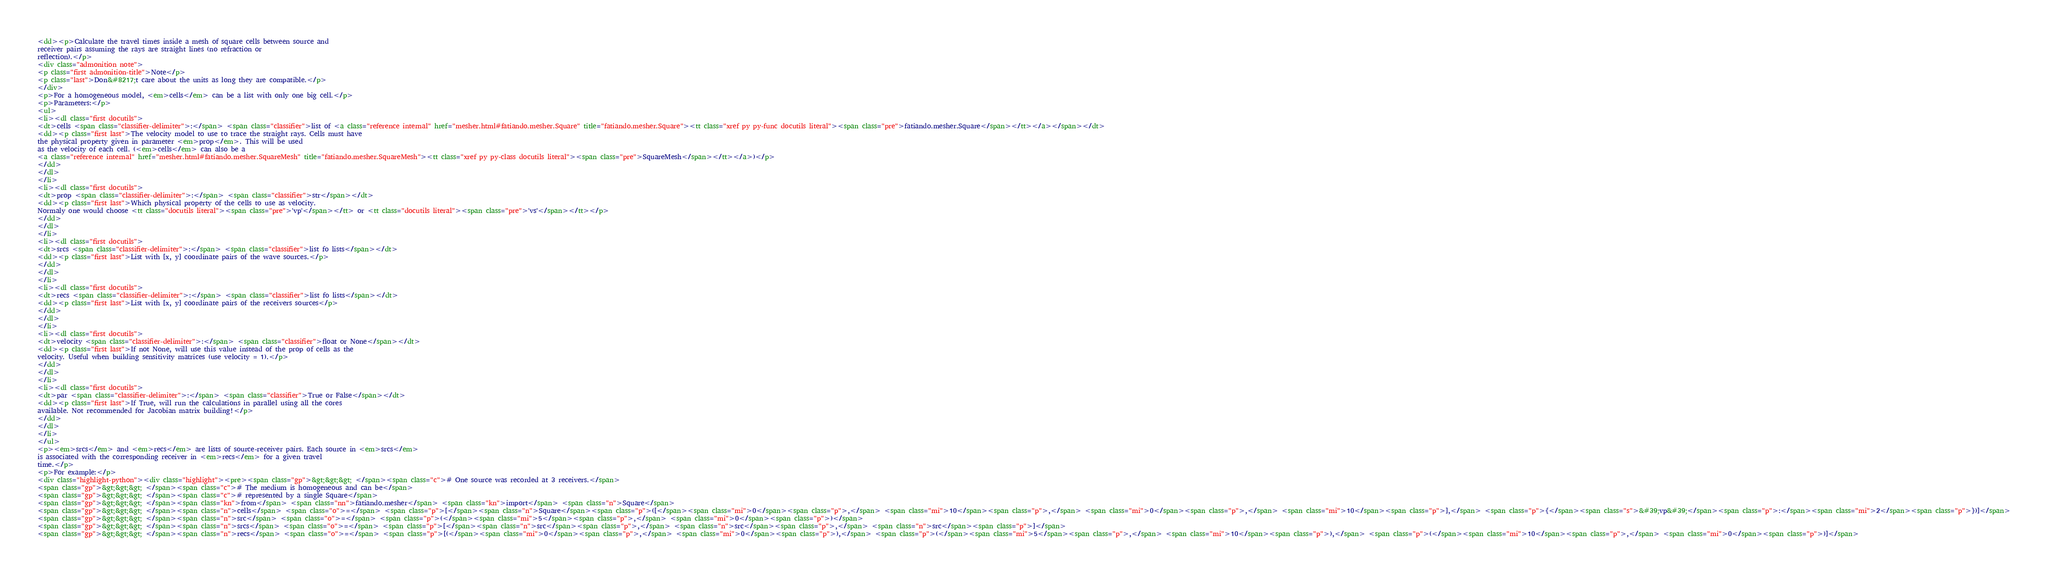Convert code to text. <code><loc_0><loc_0><loc_500><loc_500><_HTML_><dd><p>Calculate the travel times inside a mesh of square cells between source and
receiver pairs assuming the rays are straight lines (no refraction or
reflection).</p>
<div class="admonition note">
<p class="first admonition-title">Note</p>
<p class="last">Don&#8217;t care about the units as long they are compatible.</p>
</div>
<p>For a homogeneous model, <em>cells</em> can be a list with only one big cell.</p>
<p>Parameters:</p>
<ul>
<li><dl class="first docutils">
<dt>cells <span class="classifier-delimiter">:</span> <span class="classifier">list of <a class="reference internal" href="mesher.html#fatiando.mesher.Square" title="fatiando.mesher.Square"><tt class="xref py py-func docutils literal"><span class="pre">fatiando.mesher.Square</span></tt></a></span></dt>
<dd><p class="first last">The velocity model to use to trace the straight rays. Cells must have
the physical property given in parameter <em>prop</em>. This will be used
as the velocity of each cell. (<em>cells</em> can also be a
<a class="reference internal" href="mesher.html#fatiando.mesher.SquareMesh" title="fatiando.mesher.SquareMesh"><tt class="xref py py-class docutils literal"><span class="pre">SquareMesh</span></tt></a>)</p>
</dd>
</dl>
</li>
<li><dl class="first docutils">
<dt>prop <span class="classifier-delimiter">:</span> <span class="classifier">str</span></dt>
<dd><p class="first last">Which physical property of the cells to use as velocity.
Normaly one would choose <tt class="docutils literal"><span class="pre">'vp'</span></tt> or <tt class="docutils literal"><span class="pre">'vs'</span></tt></p>
</dd>
</dl>
</li>
<li><dl class="first docutils">
<dt>srcs <span class="classifier-delimiter">:</span> <span class="classifier">list fo lists</span></dt>
<dd><p class="first last">List with [x, y] coordinate pairs of the wave sources.</p>
</dd>
</dl>
</li>
<li><dl class="first docutils">
<dt>recs <span class="classifier-delimiter">:</span> <span class="classifier">list fo lists</span></dt>
<dd><p class="first last">List with [x, y] coordinate pairs of the receivers sources</p>
</dd>
</dl>
</li>
<li><dl class="first docutils">
<dt>velocity <span class="classifier-delimiter">:</span> <span class="classifier">float or None</span></dt>
<dd><p class="first last">If not None, will use this value instead of the prop of cells as the
velocity. Useful when building sensitivity matrices (use velocity = 1).</p>
</dd>
</dl>
</li>
<li><dl class="first docutils">
<dt>par <span class="classifier-delimiter">:</span> <span class="classifier">True or False</span></dt>
<dd><p class="first last">If True, will run the calculations in parallel using all the cores
available. Not recommended for Jacobian matrix building!</p>
</dd>
</dl>
</li>
</ul>
<p><em>srcs</em> and <em>recs</em> are lists of source-receiver pairs. Each source in <em>srcs</em>
is associated with the corresponding receiver in <em>recs</em> for a given travel
time.</p>
<p>For example:</p>
<div class="highlight-python"><div class="highlight"><pre><span class="gp">&gt;&gt;&gt; </span><span class="c"># One source was recorded at 3 receivers.</span>
<span class="gp">&gt;&gt;&gt; </span><span class="c"># The medium is homogeneous and can be</span>
<span class="gp">&gt;&gt;&gt; </span><span class="c"># represented by a single Square</span>
<span class="gp">&gt;&gt;&gt; </span><span class="kn">from</span> <span class="nn">fatiando.mesher</span> <span class="kn">import</span> <span class="n">Square</span>
<span class="gp">&gt;&gt;&gt; </span><span class="n">cells</span> <span class="o">=</span> <span class="p">[</span><span class="n">Square</span><span class="p">([</span><span class="mi">0</span><span class="p">,</span> <span class="mi">10</span><span class="p">,</span> <span class="mi">0</span><span class="p">,</span> <span class="mi">10</span><span class="p">],</span> <span class="p">{</span><span class="s">&#39;vp&#39;</span><span class="p">:</span><span class="mi">2</span><span class="p">})]</span>
<span class="gp">&gt;&gt;&gt; </span><span class="n">src</span> <span class="o">=</span> <span class="p">(</span><span class="mi">5</span><span class="p">,</span> <span class="mi">0</span><span class="p">)</span>
<span class="gp">&gt;&gt;&gt; </span><span class="n">srcs</span> <span class="o">=</span> <span class="p">[</span><span class="n">src</span><span class="p">,</span> <span class="n">src</span><span class="p">,</span> <span class="n">src</span><span class="p">]</span>
<span class="gp">&gt;&gt;&gt; </span><span class="n">recs</span> <span class="o">=</span> <span class="p">[(</span><span class="mi">0</span><span class="p">,</span> <span class="mi">0</span><span class="p">),</span> <span class="p">(</span><span class="mi">5</span><span class="p">,</span> <span class="mi">10</span><span class="p">),</span> <span class="p">(</span><span class="mi">10</span><span class="p">,</span> <span class="mi">0</span><span class="p">)]</span></code> 